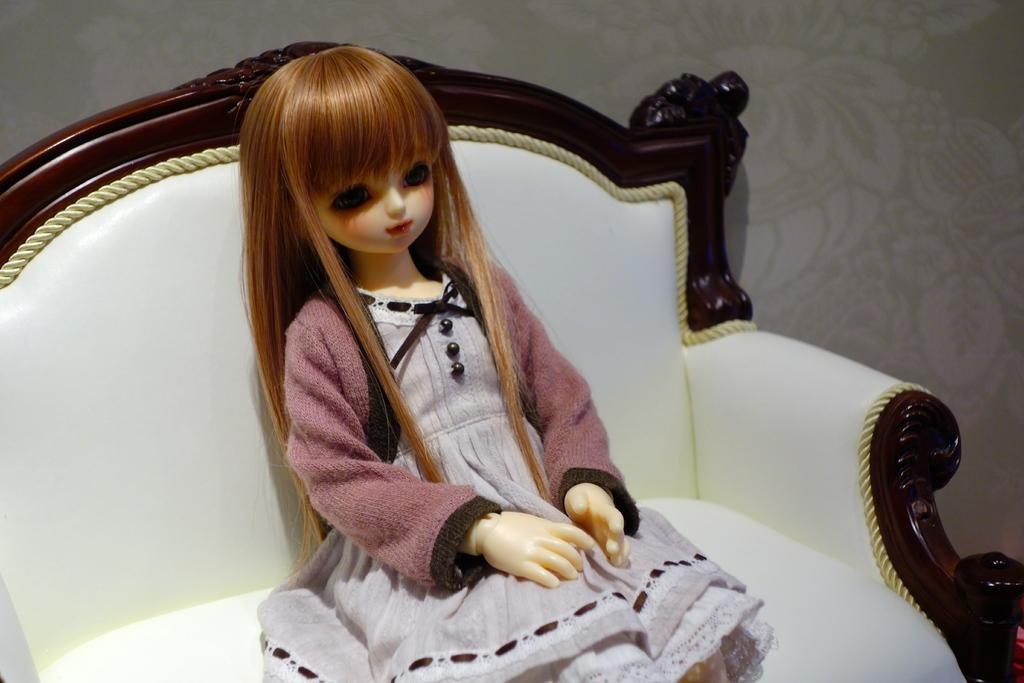What is the main subject of the image? There is a doll in the image. Where is the doll located in the image? The doll is sitting on a chair. What can be seen in the background of the image? There is a wall visible in the background of the image. What type of light effect can be seen on the doll in the image? There is no light effect visible on the doll in the image. Is there a chessboard visible in the image? There is no chessboard present in the image. 